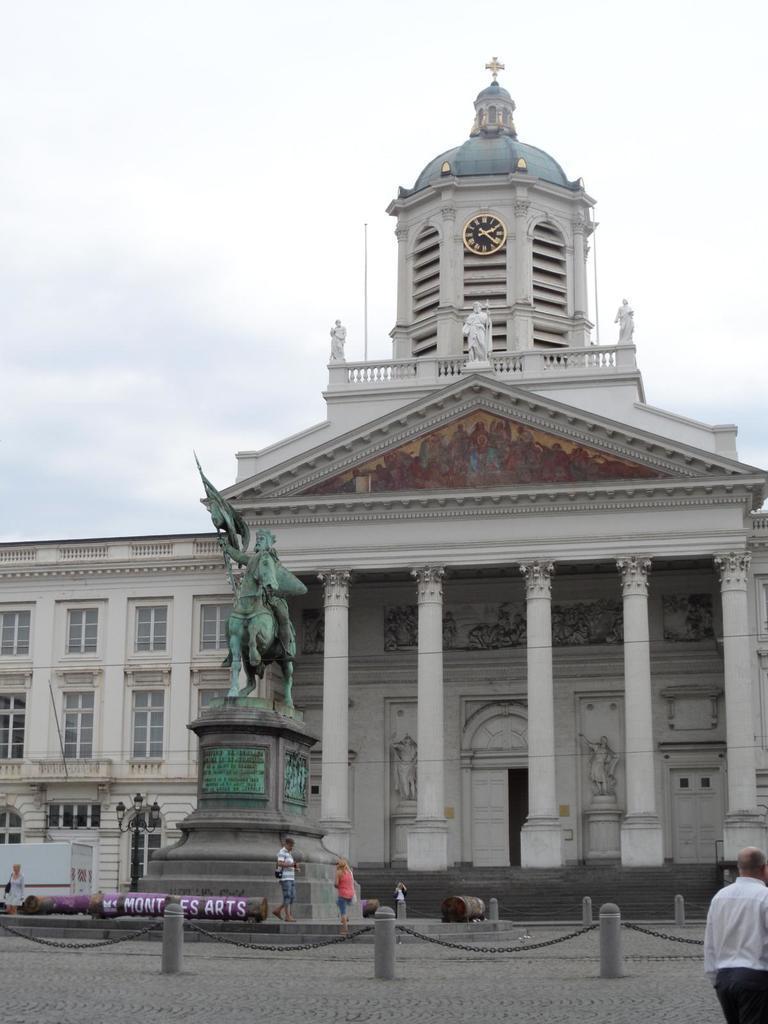In one or two sentences, can you explain what this image depicts? In this image we can see building, clock, statues, light pole, vehicle, windows, pillars, memorial stone, people, door, chains and cloudy sky. 